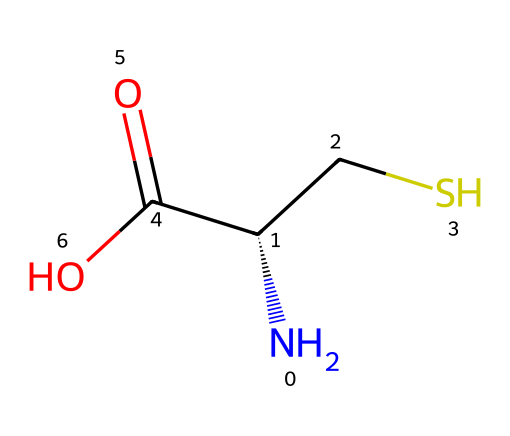what is the total number of atoms in the compound? The SMILES notation indicates that there are 4 carbon atoms (C), 1 nitrogen atom (N), 1 sulfur atom (S), and 2 oxygen atoms (O), which totals 8 sulfur-containing amino acid atoms.
Answer: 8 how many sulfur atoms are present in the structure? By examining the SMILES representation, there is one sulfur atom indicated by the "S".
Answer: 1 what type of functional group is present in this amino acid? The presence of "C(=O)O" indicates a carboxylic acid functional group, which is characteristic of amino acids.
Answer: carboxylic acid what is the stereochemistry of the carbon atom connected to the sulfur? The "C@@H" in the SMILES notation indicates that this carbon atom is chiral and has a specific stereochemistry (S configuration).
Answer: S what role do sulfur atoms typically play in amino acids? Sulfur atoms in amino acids often play a role in forming disulfide bonds that contribute to protein structure stability and function.
Answer: structural stability how is this compound classified within amino acids? The presence of sulfur, alongside the amino and carboxylic groups, classifies this compound as a sulfur-containing amino acid specifically, cysteine.
Answer: cysteine what kind of bond connects the nitrogen and carbon atoms in this structure? The bond connecting the nitrogen and the alpha carbon in this structure is a covalent bond, typical for amine functionality in amino acids.
Answer: covalent bond 